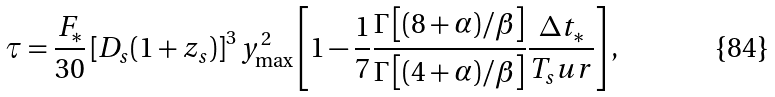<formula> <loc_0><loc_0><loc_500><loc_500>\tau = \frac { F _ { * } } { 3 0 } \left [ D _ { s } ( 1 + z _ { s } ) \right ] ^ { 3 } y _ { \max } ^ { 2 } \left [ 1 - \frac { 1 } { 7 } \frac { \Gamma \left [ ( 8 + \alpha ) / \beta \right ] } { \Gamma \left [ ( 4 + \alpha ) / \beta \right ] } \frac { \Delta t _ { * } } { T _ { s } u r } \right ] ,</formula> 